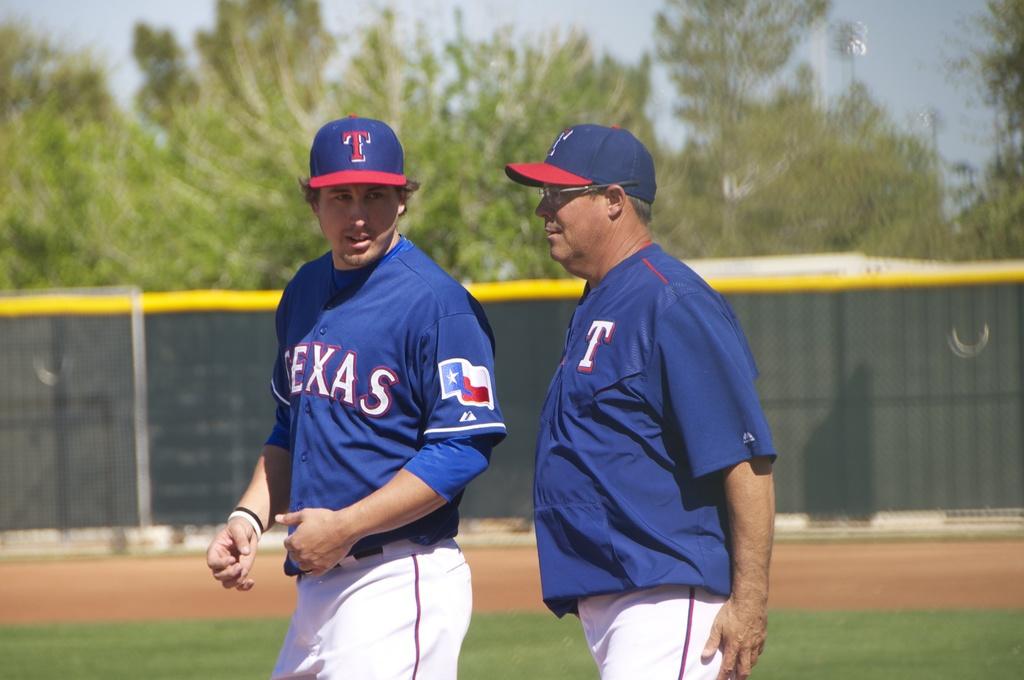What´s the letter on the t-shirt of the right?
Make the answer very short. T. 